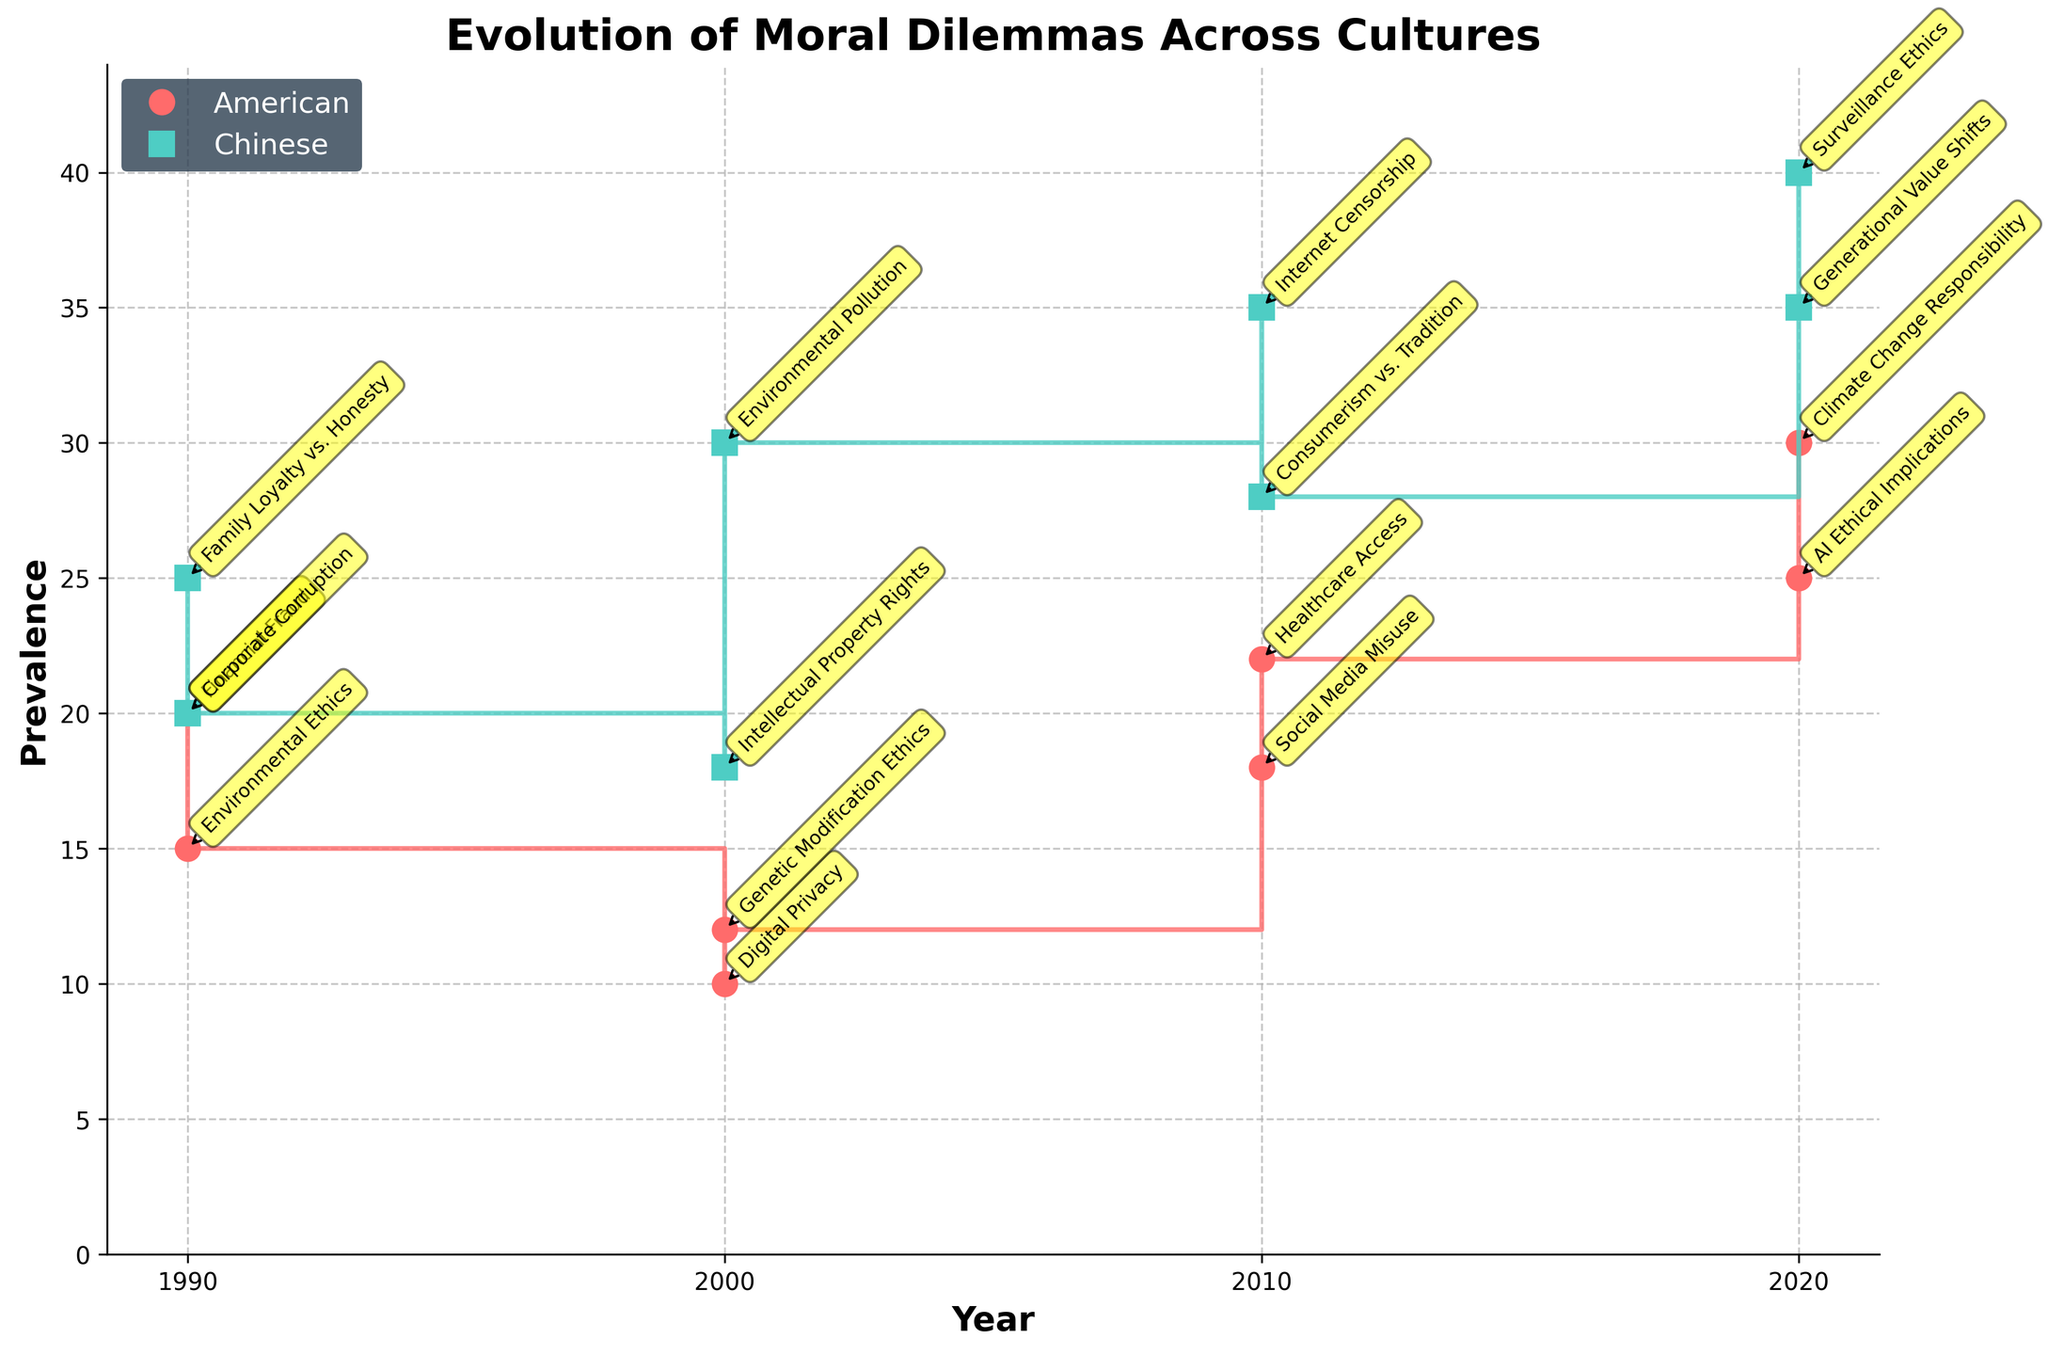What is the title of the plot? The title is located at the top center of the plot, indicating what the figure represents.
Answer: Evolution of Moral Dilemmas Across Cultures What are the cultures compared in the plot? The cultures are distinguished by the legend, where each culture is assigned a unique color and marker type.
Answer: American and Chinese Which culture faced the highest prevalence of moral dilemmas in 2020? Look at the 2020 data points and compare the heights of the prevalence markers for American and Chinese cultures.
Answer: Chinese What moral dilemmas did the American culture face in 2000? Notice the annotations next to the data points labeled for the year 2000 under the American culture.
Answer: Digital Privacy and Genetic Modification Ethics How does the prevalence of environmental-related moral dilemmas in the American culture change from 1990 to 2020? Identify the relevant years (1990 and 2020) and examine the data points related to environmental ethics. Note the increase or decrease in prevalence values.
Answer: Increased from 15 to 30 In 2010, did the Chinese culture face a higher prevalence of moral dilemmas than in 2000? Compare the height of the prevalence markers for Chinese culture between the years 2000 and 2010.
Answer: Yes What is the overall trend for the prevalence of moral dilemmas in Chinese culture from 1990 to 2020? Observe the step-like increases or decreases in the data points for Chinese culture across the years 1990, 2000, 2010, and 2020.
Answer: Increasing Which year shows the greatest disparity in moral dilemma prevalence between American and Chinese cultures? Compare the differences in prevalence for each of the years indicated (1990, 2000, 2010, 2020) and identify the year with the largest gap.
Answer: 2020 Identify two moral dilemmas faced by the Chinese culture in both 2000 and 2020. Check the annotations next to the data points for these years and identify the dilemmas listed.
Answer: Intellectual Property Rights and Environmental Pollution (2000); Surveillance Ethics and Generational Value Shifts (2020) Between 2010 and 2020, which culture saw a greater increase in the prevalence of moral dilemmas? Calculate the difference in prevalence values from 2010 to 2020 for each culture and compare them.
Answer: Chinese 